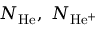<formula> <loc_0><loc_0><loc_500><loc_500>N _ { H e } , N _ { H e ^ { + } }</formula> 